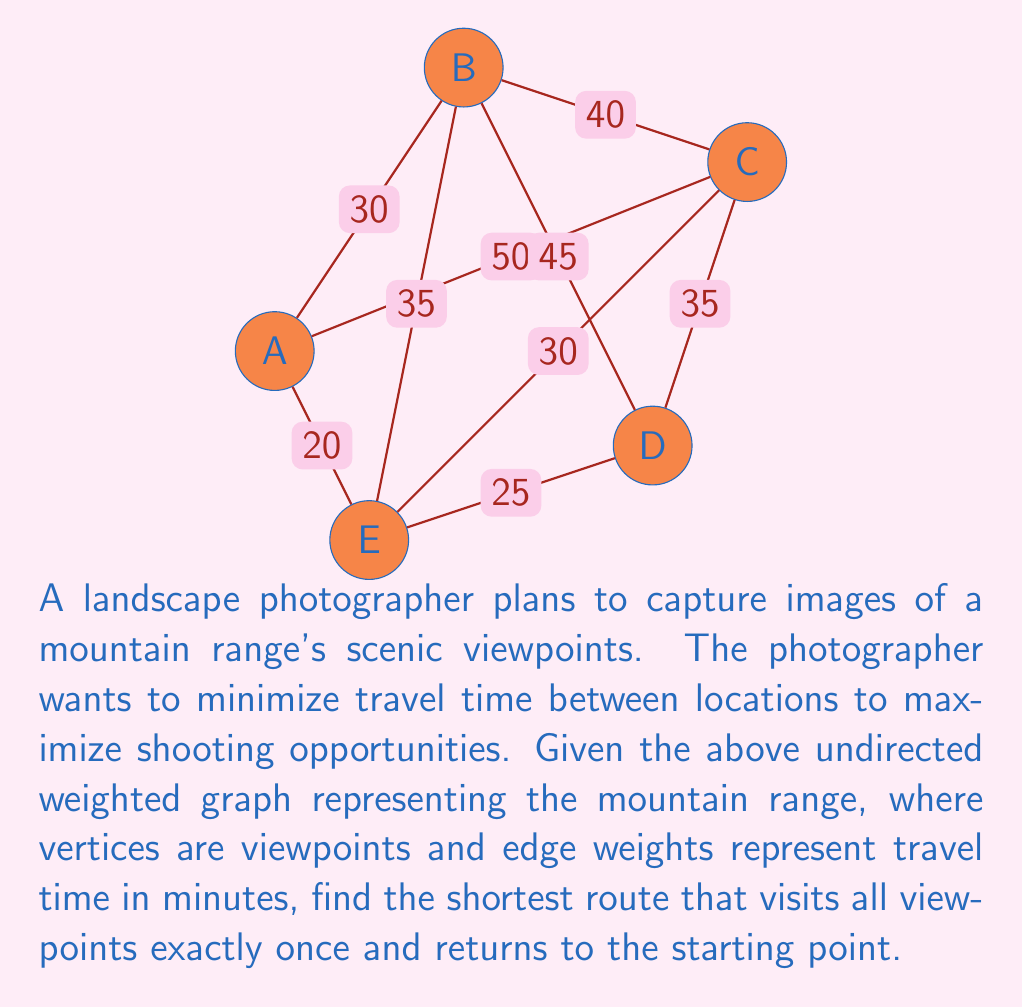Help me with this question. To solve this problem, we need to find the Hamiltonian cycle with the minimum total weight in the given graph. This is known as the Traveling Salesman Problem (TSP), which is NP-hard. For small graphs like this one, we can use a brute-force approach to find the optimal solution.

Steps to solve:

1. List all possible Hamiltonian cycles starting from vertex A:
   - A-B-C-D-E-A
   - A-B-C-E-D-A
   - A-B-D-C-E-A
   - A-B-D-E-C-A
   - A-B-E-C-D-A
   - A-B-E-D-C-A
   - A-C-B-D-E-A
   - A-C-B-E-D-A
   - A-C-D-B-E-A
   - A-C-D-E-B-A
   - A-C-E-B-D-A
   - A-C-E-D-B-A
   - A-E-B-C-D-A
   - A-E-B-D-C-A
   - A-E-C-B-D-A
   - A-E-C-D-B-A
   - A-E-D-B-C-A
   - A-E-D-C-B-A

2. Calculate the total weight for each cycle:
   - A-B-C-D-E-A: 30 + 40 + 35 + 25 + 20 = 150
   - A-B-C-E-D-A: 30 + 40 + 30 + 25 + 20 = 145
   - A-B-D-C-E-A: 30 + 45 + 35 + 30 + 20 = 160
   - A-B-D-E-C-A: 30 + 45 + 25 + 30 + 50 = 180
   - A-B-E-C-D-A: 30 + 35 + 30 + 35 + 20 = 150
   - A-B-E-D-C-A: 30 + 35 + 25 + 35 + 50 = 175
   - A-C-B-D-E-A: 50 + 40 + 45 + 25 + 20 = 180
   - A-C-B-E-D-A: 50 + 40 + 35 + 25 + 20 = 170
   - A-C-D-B-E-A: 50 + 35 + 45 + 35 + 20 = 185
   - A-C-D-E-B-A: 50 + 35 + 25 + 35 + 30 = 175
   - A-C-E-B-D-A: 50 + 30 + 35 + 45 + 20 = 180
   - A-C-E-D-B-A: 50 + 30 + 25 + 45 + 30 = 180
   - A-E-B-C-D-A: 20 + 35 + 40 + 35 + 20 = 150
   - A-E-B-D-C-A: 20 + 35 + 45 + 35 + 50 = 185
   - A-E-C-B-D-A: 20 + 30 + 40 + 45 + 20 = 155
   - A-E-C-D-B-A: 20 + 30 + 35 + 45 + 30 = 160
   - A-E-D-B-C-A: 20 + 25 + 45 + 40 + 50 = 180
   - A-E-D-C-B-A: 20 + 25 + 35 + 40 + 30 = 150

3. Identify the cycle(s) with the minimum total weight:
   There are four cycles with a minimum weight of 150:
   - A-B-C-D-E-A
   - A-B-E-C-D-A
   - A-E-B-C-D-A
   - A-E-D-C-B-A

Any of these four cycles can be chosen as the optimal solution.
Answer: The shortest route to visit all viewpoints exactly once and return to the starting point has a total travel time of 150 minutes. One possible optimal route is A-B-C-D-E-A. 